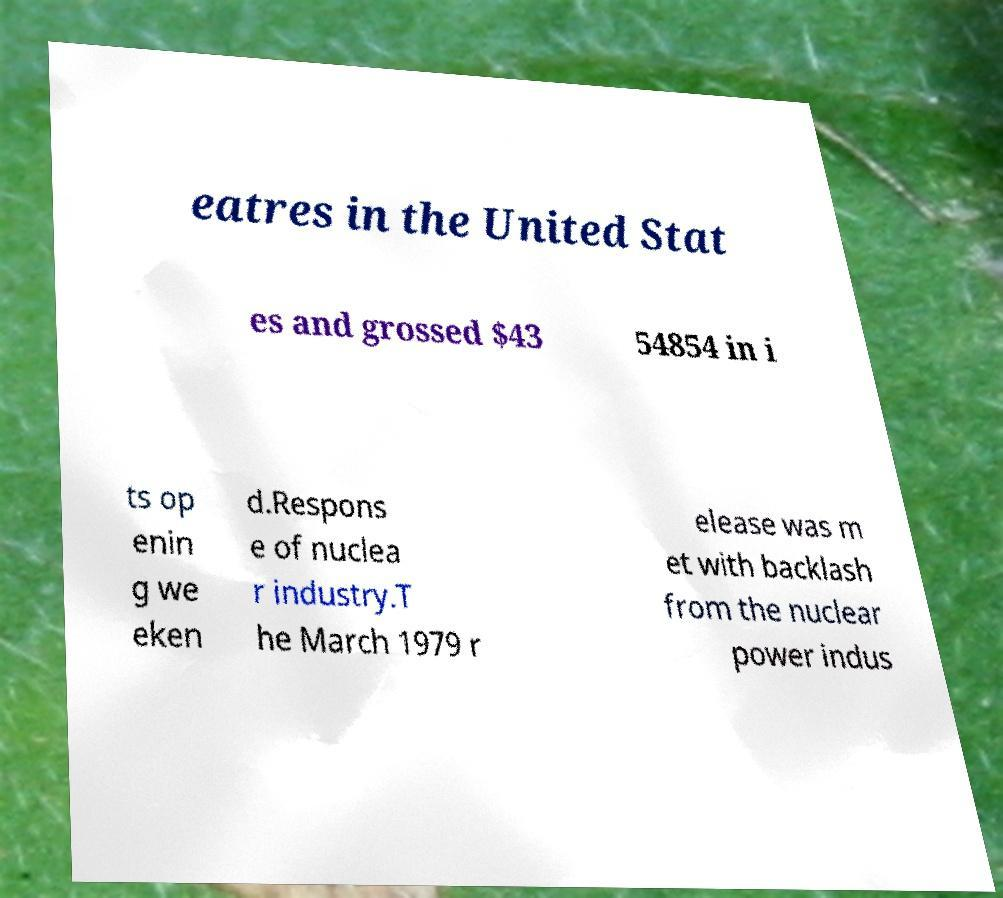Could you extract and type out the text from this image? eatres in the United Stat es and grossed $43 54854 in i ts op enin g we eken d.Respons e of nuclea r industry.T he March 1979 r elease was m et with backlash from the nuclear power indus 